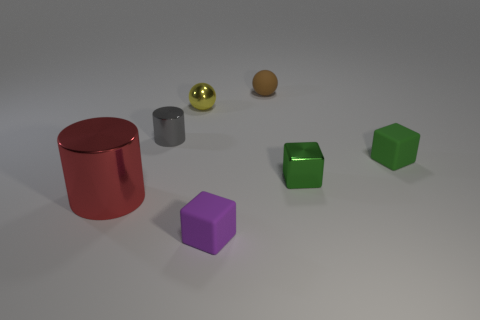What shape is the purple object that is the same material as the brown object?
Your response must be concise. Cube. What is the color of the cylinder that is the same size as the green rubber cube?
Provide a short and direct response. Gray. Does the metallic cylinder that is on the left side of the gray object have the same size as the small purple cube?
Your response must be concise. No. How many large things are there?
Offer a terse response. 1. How many blocks are either brown objects or small rubber things?
Ensure brevity in your answer.  2. How many small shiny things are on the left side of the rubber object that is behind the yellow ball?
Your response must be concise. 2. Is the material of the small brown sphere the same as the purple object?
Offer a very short reply. Yes. Are there any large cyan cubes made of the same material as the tiny yellow ball?
Your answer should be very brief. No. There is a rubber thing in front of the small rubber cube on the right side of the tiny block that is to the left of the brown object; what is its color?
Offer a very short reply. Purple. What number of cyan things are either large metallic objects or rubber objects?
Make the answer very short. 0. 